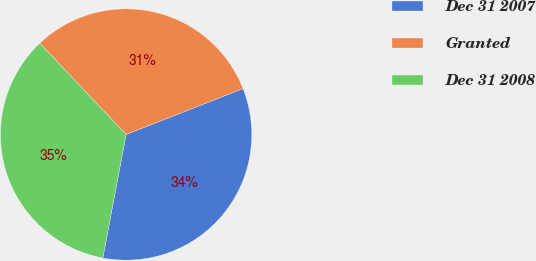Convert chart. <chart><loc_0><loc_0><loc_500><loc_500><pie_chart><fcel>Dec 31 2007<fcel>Granted<fcel>Dec 31 2008<nl><fcel>33.92%<fcel>31.1%<fcel>34.97%<nl></chart> 